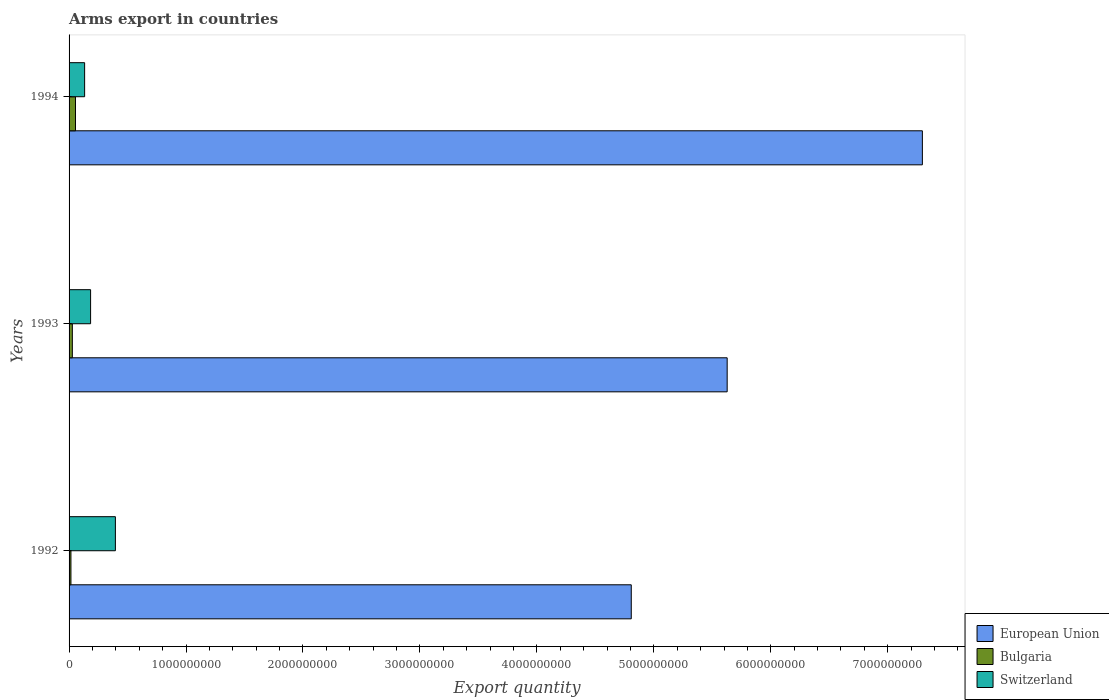How many different coloured bars are there?
Give a very brief answer. 3. Are the number of bars on each tick of the Y-axis equal?
Provide a succinct answer. Yes. How many bars are there on the 3rd tick from the top?
Give a very brief answer. 3. How many bars are there on the 3rd tick from the bottom?
Offer a very short reply. 3. What is the label of the 1st group of bars from the top?
Keep it short and to the point. 1994. What is the total arms export in Switzerland in 1993?
Keep it short and to the point. 1.84e+08. Across all years, what is the maximum total arms export in European Union?
Offer a terse response. 7.30e+09. Across all years, what is the minimum total arms export in Switzerland?
Offer a very short reply. 1.33e+08. In which year was the total arms export in Switzerland minimum?
Offer a terse response. 1994. What is the total total arms export in Switzerland in the graph?
Your answer should be very brief. 7.13e+08. What is the difference between the total arms export in Switzerland in 1992 and that in 1994?
Your response must be concise. 2.63e+08. What is the difference between the total arms export in Bulgaria in 1992 and the total arms export in Switzerland in 1994?
Make the answer very short. -1.17e+08. What is the average total arms export in Bulgaria per year?
Keep it short and to the point. 3.30e+07. In the year 1992, what is the difference between the total arms export in Bulgaria and total arms export in Switzerland?
Make the answer very short. -3.80e+08. In how many years, is the total arms export in European Union greater than 5400000000 ?
Your answer should be very brief. 2. What is the ratio of the total arms export in European Union in 1992 to that in 1994?
Ensure brevity in your answer.  0.66. What is the difference between the highest and the second highest total arms export in Switzerland?
Your response must be concise. 2.12e+08. What is the difference between the highest and the lowest total arms export in Switzerland?
Provide a succinct answer. 2.63e+08. Is the sum of the total arms export in Bulgaria in 1992 and 1994 greater than the maximum total arms export in European Union across all years?
Your answer should be very brief. No. What does the 1st bar from the top in 1993 represents?
Offer a terse response. Switzerland. What does the 2nd bar from the bottom in 1992 represents?
Provide a succinct answer. Bulgaria. Is it the case that in every year, the sum of the total arms export in Bulgaria and total arms export in European Union is greater than the total arms export in Switzerland?
Provide a succinct answer. Yes. How many bars are there?
Ensure brevity in your answer.  9. Are all the bars in the graph horizontal?
Provide a succinct answer. Yes. Does the graph contain grids?
Ensure brevity in your answer.  No. Where does the legend appear in the graph?
Give a very brief answer. Bottom right. What is the title of the graph?
Your answer should be very brief. Arms export in countries. Does "Northern Mariana Islands" appear as one of the legend labels in the graph?
Give a very brief answer. No. What is the label or title of the X-axis?
Keep it short and to the point. Export quantity. What is the label or title of the Y-axis?
Offer a very short reply. Years. What is the Export quantity of European Union in 1992?
Provide a short and direct response. 4.81e+09. What is the Export quantity in Bulgaria in 1992?
Your answer should be very brief. 1.60e+07. What is the Export quantity of Switzerland in 1992?
Your answer should be very brief. 3.96e+08. What is the Export quantity of European Union in 1993?
Provide a short and direct response. 5.63e+09. What is the Export quantity in Bulgaria in 1993?
Your answer should be very brief. 2.80e+07. What is the Export quantity in Switzerland in 1993?
Your response must be concise. 1.84e+08. What is the Export quantity in European Union in 1994?
Make the answer very short. 7.30e+09. What is the Export quantity of Bulgaria in 1994?
Offer a terse response. 5.50e+07. What is the Export quantity of Switzerland in 1994?
Provide a succinct answer. 1.33e+08. Across all years, what is the maximum Export quantity of European Union?
Your answer should be very brief. 7.30e+09. Across all years, what is the maximum Export quantity in Bulgaria?
Your answer should be compact. 5.50e+07. Across all years, what is the maximum Export quantity of Switzerland?
Offer a very short reply. 3.96e+08. Across all years, what is the minimum Export quantity of European Union?
Your answer should be compact. 4.81e+09. Across all years, what is the minimum Export quantity in Bulgaria?
Offer a terse response. 1.60e+07. Across all years, what is the minimum Export quantity in Switzerland?
Keep it short and to the point. 1.33e+08. What is the total Export quantity of European Union in the graph?
Ensure brevity in your answer.  1.77e+1. What is the total Export quantity in Bulgaria in the graph?
Give a very brief answer. 9.90e+07. What is the total Export quantity in Switzerland in the graph?
Your answer should be very brief. 7.13e+08. What is the difference between the Export quantity in European Union in 1992 and that in 1993?
Your answer should be very brief. -8.20e+08. What is the difference between the Export quantity in Bulgaria in 1992 and that in 1993?
Provide a succinct answer. -1.20e+07. What is the difference between the Export quantity in Switzerland in 1992 and that in 1993?
Keep it short and to the point. 2.12e+08. What is the difference between the Export quantity in European Union in 1992 and that in 1994?
Your answer should be very brief. -2.49e+09. What is the difference between the Export quantity of Bulgaria in 1992 and that in 1994?
Provide a short and direct response. -3.90e+07. What is the difference between the Export quantity of Switzerland in 1992 and that in 1994?
Keep it short and to the point. 2.63e+08. What is the difference between the Export quantity of European Union in 1993 and that in 1994?
Offer a terse response. -1.67e+09. What is the difference between the Export quantity in Bulgaria in 1993 and that in 1994?
Make the answer very short. -2.70e+07. What is the difference between the Export quantity in Switzerland in 1993 and that in 1994?
Your answer should be compact. 5.10e+07. What is the difference between the Export quantity in European Union in 1992 and the Export quantity in Bulgaria in 1993?
Your answer should be compact. 4.78e+09. What is the difference between the Export quantity of European Union in 1992 and the Export quantity of Switzerland in 1993?
Ensure brevity in your answer.  4.62e+09. What is the difference between the Export quantity in Bulgaria in 1992 and the Export quantity in Switzerland in 1993?
Your response must be concise. -1.68e+08. What is the difference between the Export quantity in European Union in 1992 and the Export quantity in Bulgaria in 1994?
Ensure brevity in your answer.  4.75e+09. What is the difference between the Export quantity of European Union in 1992 and the Export quantity of Switzerland in 1994?
Provide a succinct answer. 4.67e+09. What is the difference between the Export quantity of Bulgaria in 1992 and the Export quantity of Switzerland in 1994?
Offer a terse response. -1.17e+08. What is the difference between the Export quantity in European Union in 1993 and the Export quantity in Bulgaria in 1994?
Keep it short and to the point. 5.57e+09. What is the difference between the Export quantity of European Union in 1993 and the Export quantity of Switzerland in 1994?
Your answer should be very brief. 5.49e+09. What is the difference between the Export quantity in Bulgaria in 1993 and the Export quantity in Switzerland in 1994?
Make the answer very short. -1.05e+08. What is the average Export quantity of European Union per year?
Your response must be concise. 5.91e+09. What is the average Export quantity in Bulgaria per year?
Provide a succinct answer. 3.30e+07. What is the average Export quantity of Switzerland per year?
Ensure brevity in your answer.  2.38e+08. In the year 1992, what is the difference between the Export quantity of European Union and Export quantity of Bulgaria?
Provide a succinct answer. 4.79e+09. In the year 1992, what is the difference between the Export quantity of European Union and Export quantity of Switzerland?
Ensure brevity in your answer.  4.41e+09. In the year 1992, what is the difference between the Export quantity in Bulgaria and Export quantity in Switzerland?
Your response must be concise. -3.80e+08. In the year 1993, what is the difference between the Export quantity in European Union and Export quantity in Bulgaria?
Keep it short and to the point. 5.60e+09. In the year 1993, what is the difference between the Export quantity of European Union and Export quantity of Switzerland?
Your answer should be very brief. 5.44e+09. In the year 1993, what is the difference between the Export quantity of Bulgaria and Export quantity of Switzerland?
Keep it short and to the point. -1.56e+08. In the year 1994, what is the difference between the Export quantity in European Union and Export quantity in Bulgaria?
Your answer should be compact. 7.24e+09. In the year 1994, what is the difference between the Export quantity of European Union and Export quantity of Switzerland?
Make the answer very short. 7.16e+09. In the year 1994, what is the difference between the Export quantity of Bulgaria and Export quantity of Switzerland?
Ensure brevity in your answer.  -7.80e+07. What is the ratio of the Export quantity in European Union in 1992 to that in 1993?
Give a very brief answer. 0.85. What is the ratio of the Export quantity of Switzerland in 1992 to that in 1993?
Give a very brief answer. 2.15. What is the ratio of the Export quantity in European Union in 1992 to that in 1994?
Offer a very short reply. 0.66. What is the ratio of the Export quantity of Bulgaria in 1992 to that in 1994?
Make the answer very short. 0.29. What is the ratio of the Export quantity in Switzerland in 1992 to that in 1994?
Offer a very short reply. 2.98. What is the ratio of the Export quantity of European Union in 1993 to that in 1994?
Provide a short and direct response. 0.77. What is the ratio of the Export quantity in Bulgaria in 1993 to that in 1994?
Ensure brevity in your answer.  0.51. What is the ratio of the Export quantity of Switzerland in 1993 to that in 1994?
Keep it short and to the point. 1.38. What is the difference between the highest and the second highest Export quantity in European Union?
Your answer should be compact. 1.67e+09. What is the difference between the highest and the second highest Export quantity of Bulgaria?
Ensure brevity in your answer.  2.70e+07. What is the difference between the highest and the second highest Export quantity of Switzerland?
Your response must be concise. 2.12e+08. What is the difference between the highest and the lowest Export quantity in European Union?
Provide a short and direct response. 2.49e+09. What is the difference between the highest and the lowest Export quantity in Bulgaria?
Make the answer very short. 3.90e+07. What is the difference between the highest and the lowest Export quantity in Switzerland?
Offer a very short reply. 2.63e+08. 